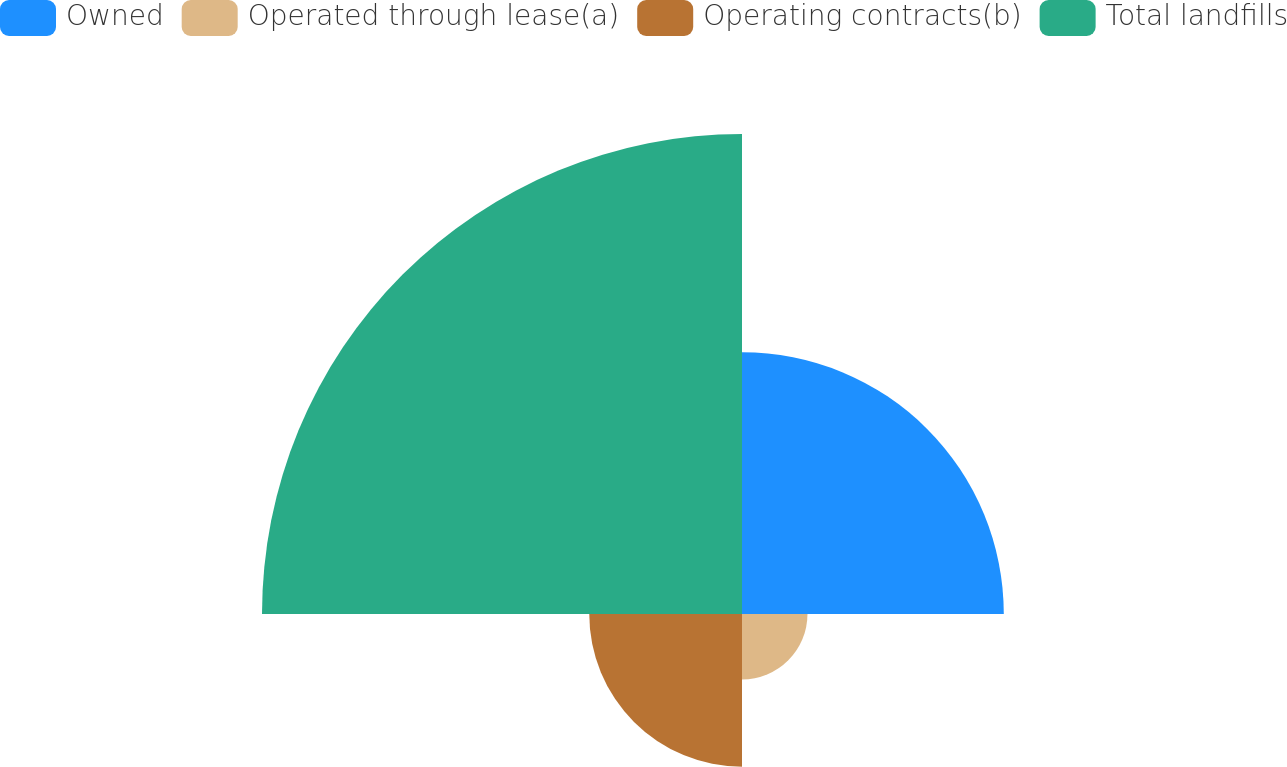Convert chart. <chart><loc_0><loc_0><loc_500><loc_500><pie_chart><fcel>Owned<fcel>Operated through lease(a)<fcel>Operating contracts(b)<fcel>Total landfills<nl><fcel>27.27%<fcel>6.82%<fcel>15.91%<fcel>50.0%<nl></chart> 